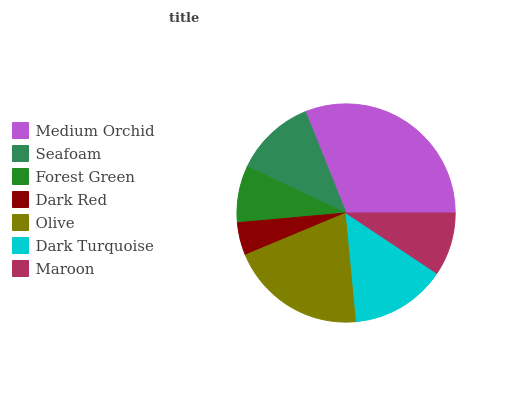Is Dark Red the minimum?
Answer yes or no. Yes. Is Medium Orchid the maximum?
Answer yes or no. Yes. Is Seafoam the minimum?
Answer yes or no. No. Is Seafoam the maximum?
Answer yes or no. No. Is Medium Orchid greater than Seafoam?
Answer yes or no. Yes. Is Seafoam less than Medium Orchid?
Answer yes or no. Yes. Is Seafoam greater than Medium Orchid?
Answer yes or no. No. Is Medium Orchid less than Seafoam?
Answer yes or no. No. Is Seafoam the high median?
Answer yes or no. Yes. Is Seafoam the low median?
Answer yes or no. Yes. Is Dark Turquoise the high median?
Answer yes or no. No. Is Maroon the low median?
Answer yes or no. No. 